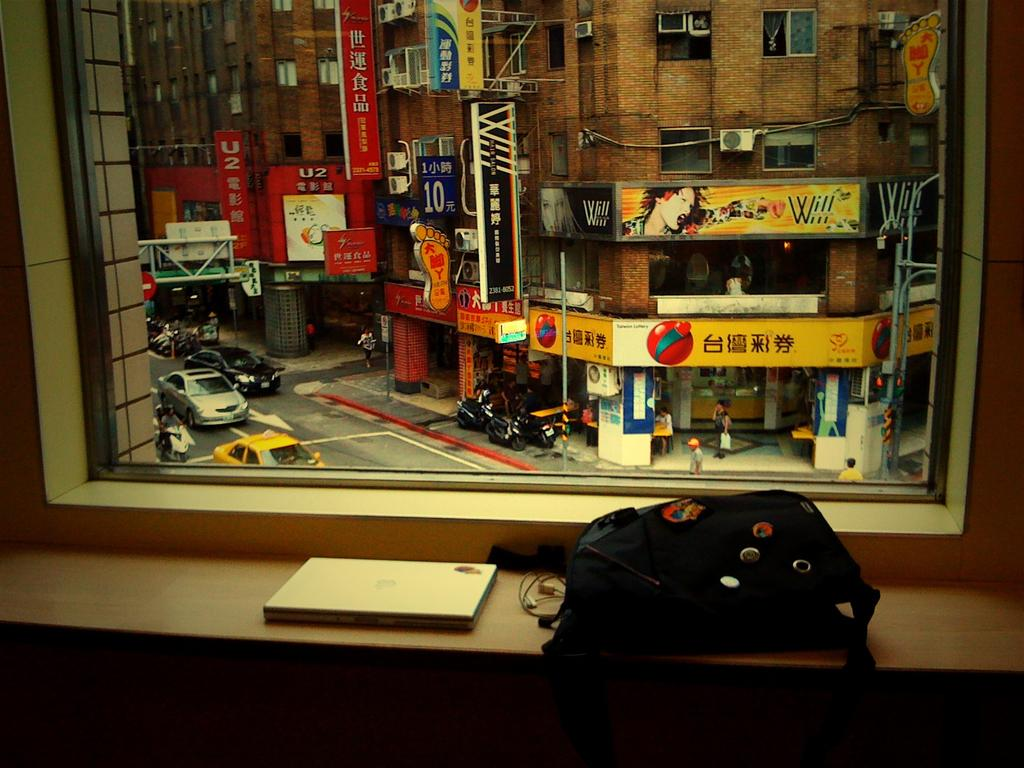What object is present in the image that can hold a liquid? There is a glass in the image. What object is present in the image that can be read? There is a book in the image. What object is present in the image that can carry items? There is a bag in the image. What can be seen from the glass in the image? Buildings, hoardings, boards, bikes, cars, and people can be seen from the glass in the image. What type of glove is being used to cause a reaction in the image? There is no glove present in the image, and no reaction is taking place. 